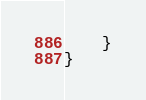Convert code to text. <code><loc_0><loc_0><loc_500><loc_500><_Java_>    }
}
</code> 